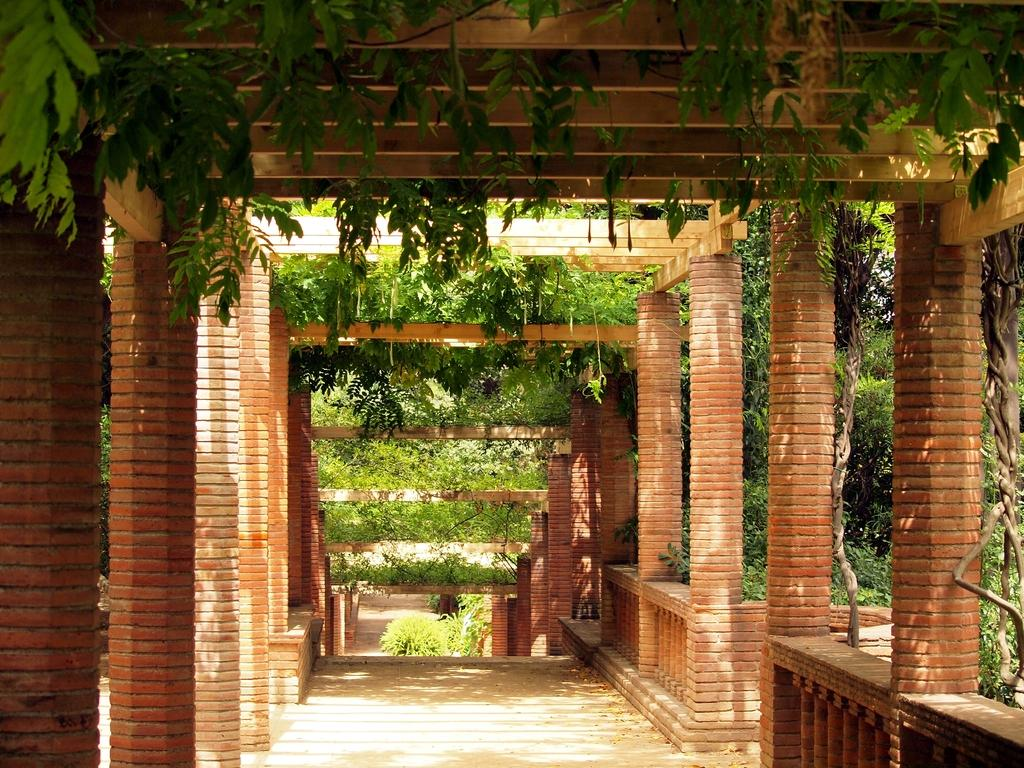What type of location is depicted in the image? The image appears to depict an outdoor garden. What architectural features can be seen in the garden? There are pillars in the garden. Are there any paths or walkways in the garden? Yes, there are stairs leading downwards in the garden. What type of vegetation is present in the garden? There are plants in the garden. What type of knife can be seen in the garden? There is no knife present in the image; it depicts an outdoor garden with plants, pillars, and stairs. 